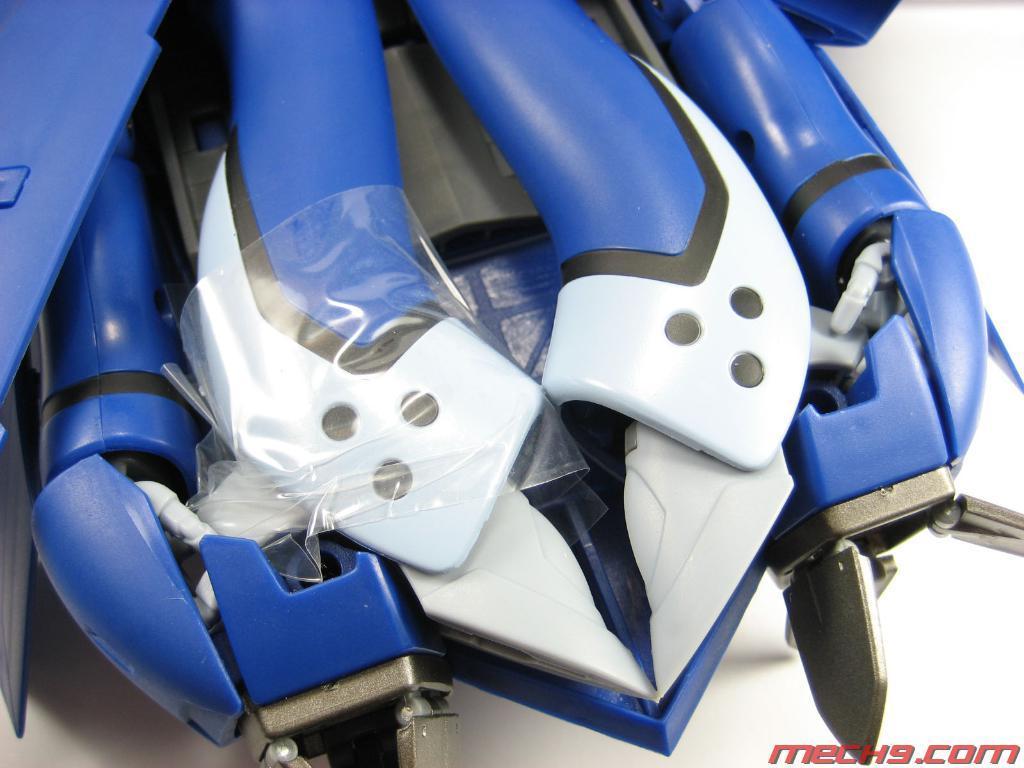Describe this image in one or two sentences. In this image I can see there is a blue color toy placed on a white surface. 